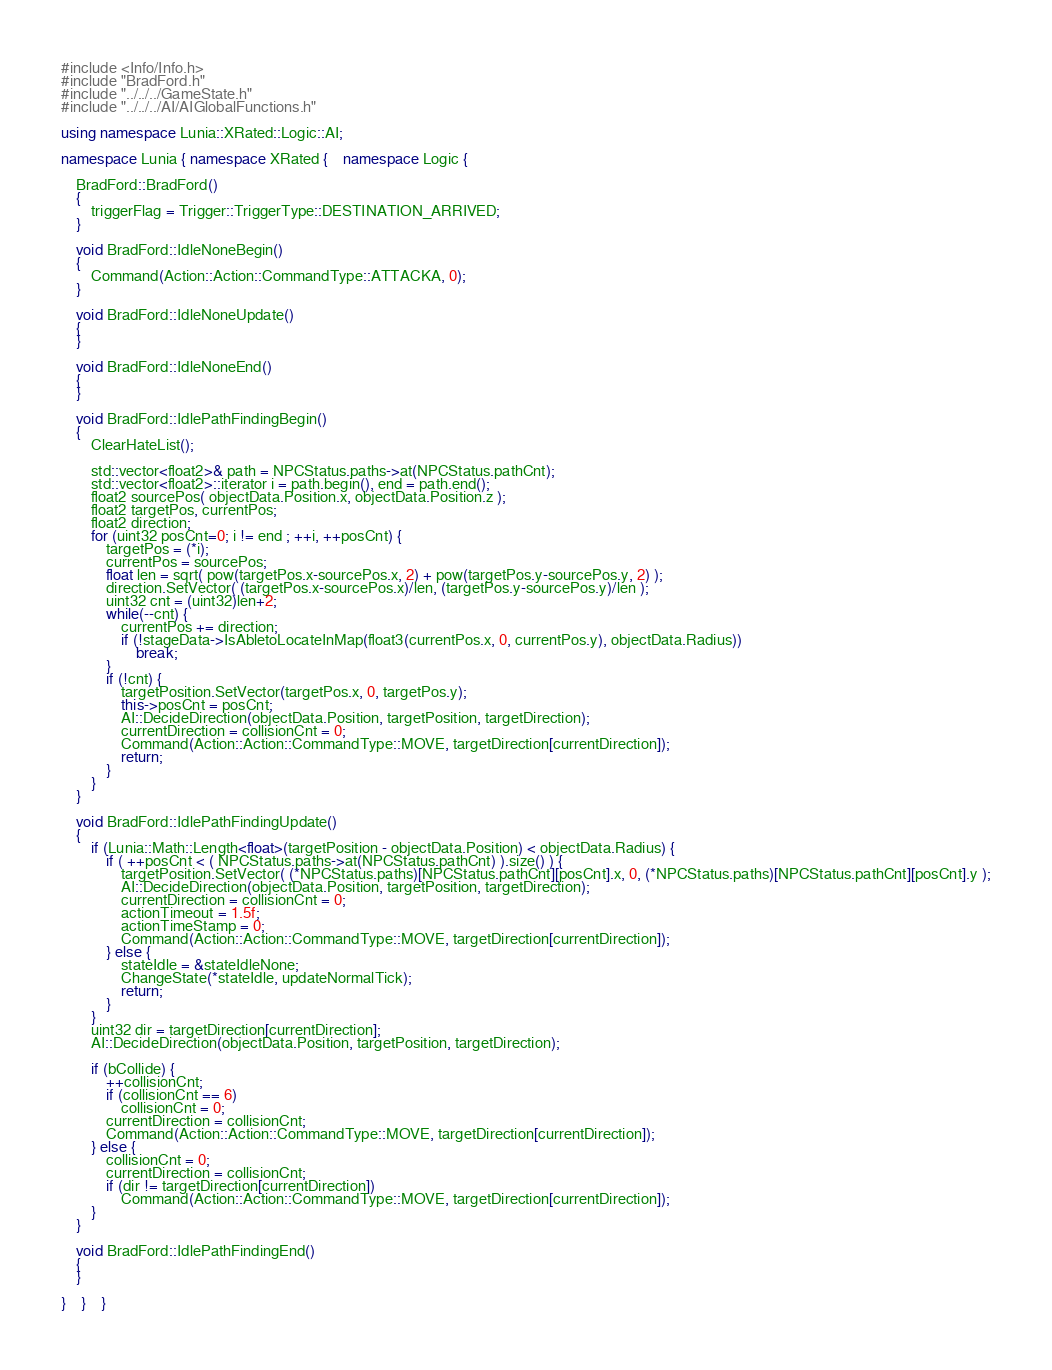Convert code to text. <code><loc_0><loc_0><loc_500><loc_500><_C++_>#include <Info/Info.h>
#include "BradFord.h"
#include "../../../GameState.h"
#include "../../../AI/AIGlobalFunctions.h"

using namespace Lunia::XRated::Logic::AI;

namespace Lunia { namespace XRated {	namespace Logic {

	BradFord::BradFord()
	{
		triggerFlag = Trigger::TriggerType::DESTINATION_ARRIVED;
	}

	void BradFord::IdleNoneBegin()
	{
		Command(Action::Action::CommandType::ATTACKA, 0);
	}

	void BradFord::IdleNoneUpdate()
	{
	}

	void BradFord::IdleNoneEnd()
	{
	}

	void BradFord::IdlePathFindingBegin()
	{
		ClearHateList();

		std::vector<float2>& path = NPCStatus.paths->at(NPCStatus.pathCnt);
		std::vector<float2>::iterator i = path.begin(), end = path.end();
		float2 sourcePos( objectData.Position.x, objectData.Position.z );
		float2 targetPos, currentPos;
		float2 direction;
		for (uint32 posCnt=0; i != end ; ++i, ++posCnt) {
            targetPos = (*i);
			currentPos = sourcePos;
			float len = sqrt( pow(targetPos.x-sourcePos.x, 2) + pow(targetPos.y-sourcePos.y, 2) );
			direction.SetVector( (targetPos.x-sourcePos.x)/len, (targetPos.y-sourcePos.y)/len );
			uint32 cnt = (uint32)len+2;
			while(--cnt) {
				currentPos += direction;
				if (!stageData->IsAbletoLocateInMap(float3(currentPos.x, 0, currentPos.y), objectData.Radius))
					break;
			}
			if (!cnt) {
				targetPosition.SetVector(targetPos.x, 0, targetPos.y);
				this->posCnt = posCnt;
				AI::DecideDirection(objectData.Position, targetPosition, targetDirection);
				currentDirection = collisionCnt = 0;
				Command(Action::Action::CommandType::MOVE, targetDirection[currentDirection]);
				return;
			}
		}
	}

	void BradFord::IdlePathFindingUpdate()
	{
		if (Lunia::Math::Length<float>(targetPosition - objectData.Position) < objectData.Radius) {
			if ( ++posCnt < ( NPCStatus.paths->at(NPCStatus.pathCnt) ).size() ) {
				targetPosition.SetVector( (*NPCStatus.paths)[NPCStatus.pathCnt][posCnt].x, 0, (*NPCStatus.paths)[NPCStatus.pathCnt][posCnt].y );
				AI::DecideDirection(objectData.Position, targetPosition, targetDirection);
				currentDirection = collisionCnt = 0;
				actionTimeout = 1.5f;
				actionTimeStamp = 0;
				Command(Action::Action::CommandType::MOVE, targetDirection[currentDirection]);
			} else {
				stateIdle = &stateIdleNone;
				ChangeState(*stateIdle, updateNormalTick);
				return;
			}
		}
		uint32 dir = targetDirection[currentDirection];
		AI::DecideDirection(objectData.Position, targetPosition, targetDirection);

		if (bCollide) {
			++collisionCnt;
			if (collisionCnt == 6)
				collisionCnt = 0;
			currentDirection = collisionCnt;
			Command(Action::Action::CommandType::MOVE, targetDirection[currentDirection]);
		} else {
			collisionCnt = 0;
			currentDirection = collisionCnt;
			if (dir != targetDirection[currentDirection])
				Command(Action::Action::CommandType::MOVE, targetDirection[currentDirection]);
		}
	}

	void BradFord::IdlePathFindingEnd()
	{
	}

}	}	}

</code> 